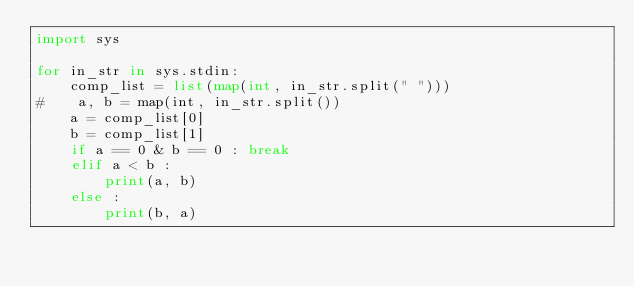Convert code to text. <code><loc_0><loc_0><loc_500><loc_500><_Python_>import sys

for in_str in sys.stdin:
    comp_list = list(map(int, in_str.split(" ")))
#    a, b = map(int, in_str.split())
    a = comp_list[0]
    b = comp_list[1]
    if a == 0 & b == 0 : break
    elif a < b :
        print(a, b)
    else :
        print(b, a)</code> 